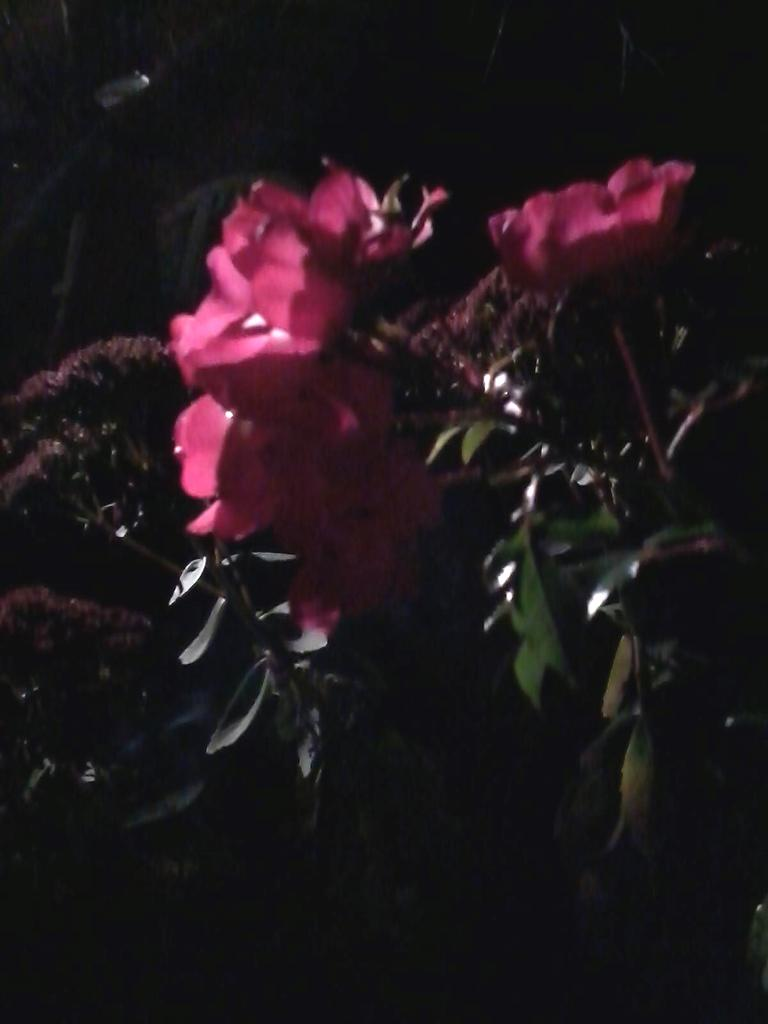What type of living organisms can be seen in the image? There are plants with flowers in the image. What can be observed about the background of the image? The background of the image is dark. What type of fan is visible in the image? There is no fan present in the image. How many crates are stacked in the image? There are no crates present in the image. 